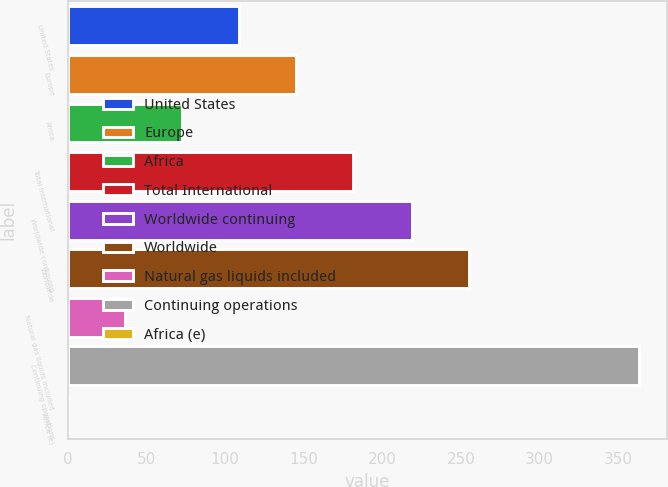Convert chart to OTSL. <chart><loc_0><loc_0><loc_500><loc_500><bar_chart><fcel>United States<fcel>Europe<fcel>Africa<fcel>Total International<fcel>Worldwide continuing<fcel>Worldwide<fcel>Natural gas liquids included<fcel>Continuing operations<fcel>Africa (e)<nl><fcel>109.08<fcel>145.36<fcel>72.8<fcel>181.64<fcel>219<fcel>255.28<fcel>36.52<fcel>363<fcel>0.24<nl></chart> 